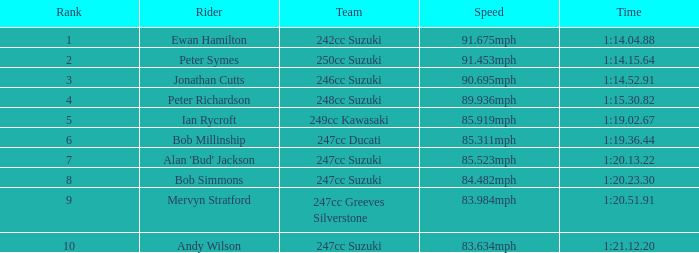What was the speed for the rider with a time of 1:14.15.64? 91.453mph. 